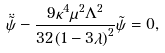Convert formula to latex. <formula><loc_0><loc_0><loc_500><loc_500>\ddot { \tilde { \psi } } - \frac { 9 \kappa ^ { 4 } \mu ^ { 2 } \Lambda ^ { 2 } } { { 3 2 \left ( { 1 - 3 \lambda } \right ) ^ { 2 } } } \tilde { \psi } = 0 ,</formula> 